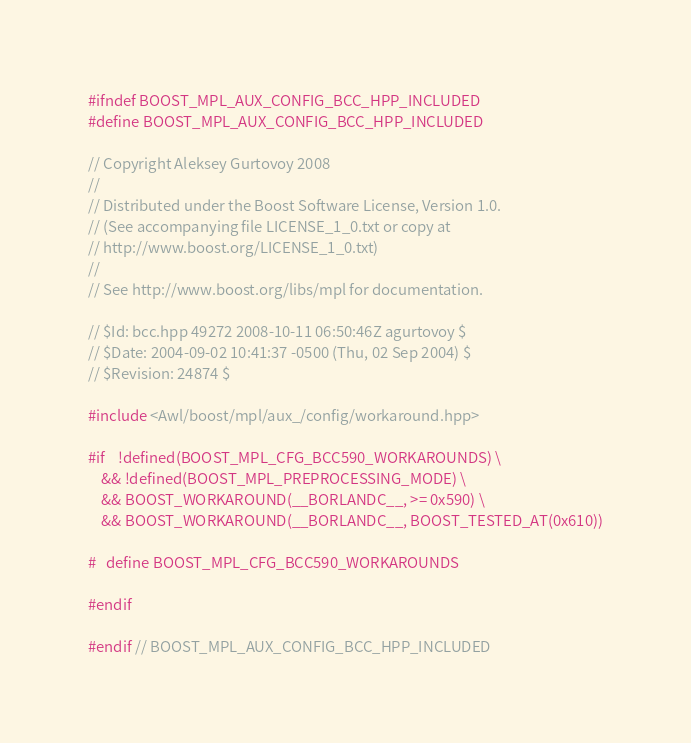Convert code to text. <code><loc_0><loc_0><loc_500><loc_500><_C++_>
#ifndef BOOST_MPL_AUX_CONFIG_BCC_HPP_INCLUDED
#define BOOST_MPL_AUX_CONFIG_BCC_HPP_INCLUDED

// Copyright Aleksey Gurtovoy 2008
//
// Distributed under the Boost Software License, Version 1.0. 
// (See accompanying file LICENSE_1_0.txt or copy at 
// http://www.boost.org/LICENSE_1_0.txt)
//
// See http://www.boost.org/libs/mpl for documentation.

// $Id: bcc.hpp 49272 2008-10-11 06:50:46Z agurtovoy $
// $Date: 2004-09-02 10:41:37 -0500 (Thu, 02 Sep 2004) $
// $Revision: 24874 $

#include <Awl/boost/mpl/aux_/config/workaround.hpp>

#if    !defined(BOOST_MPL_CFG_BCC590_WORKAROUNDS) \
    && !defined(BOOST_MPL_PREPROCESSING_MODE) \
    && BOOST_WORKAROUND(__BORLANDC__, >= 0x590) \
    && BOOST_WORKAROUND(__BORLANDC__, BOOST_TESTED_AT(0x610))

#   define BOOST_MPL_CFG_BCC590_WORKAROUNDS

#endif

#endif // BOOST_MPL_AUX_CONFIG_BCC_HPP_INCLUDED
</code> 